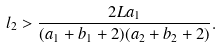Convert formula to latex. <formula><loc_0><loc_0><loc_500><loc_500>l _ { 2 } > \frac { 2 L a _ { 1 } } { ( a _ { 1 } + b _ { 1 } + 2 ) ( a _ { 2 } + b _ { 2 } + 2 ) } .</formula> 